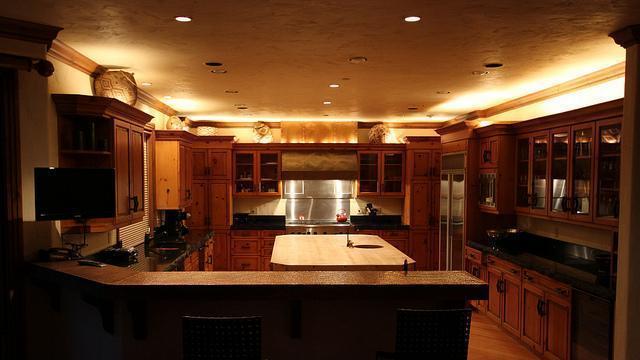What color is the water kettle on the top of the oven in the back of the kitchen?
Pick the correct solution from the four options below to address the question.
Options: Green, red, blue, yellow. Red. 